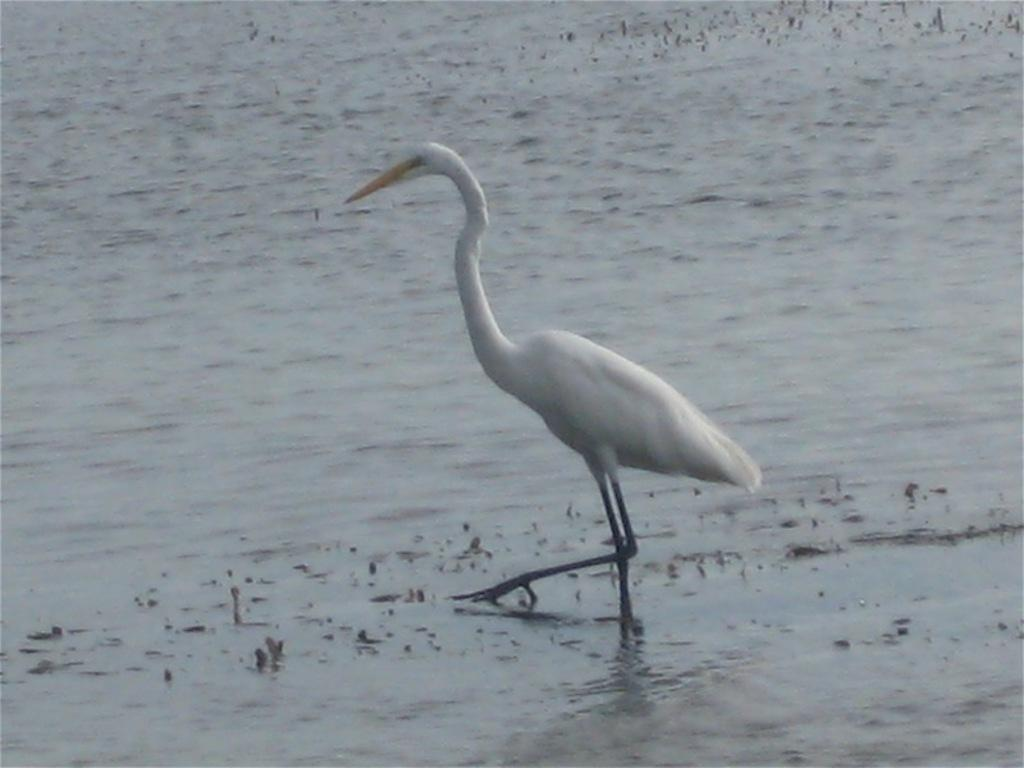Where was the image taken? The image is taken outdoors. What can be seen at the bottom of the image? There is a pond with water at the bottom of the image. What is the main subject in the middle of the image? There is a crane in the middle of the image. What type of badge is the crane wearing in the image? There is no badge present on the crane in the image. How does the crane's behavior change throughout the image? The image is a still photograph, so the crane's behavior does not change throughout the image. 